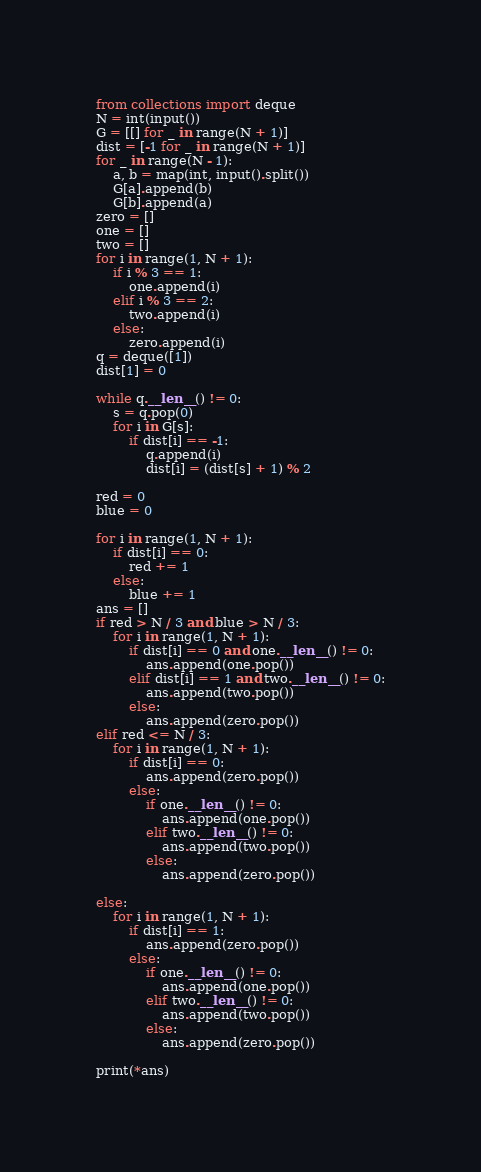<code> <loc_0><loc_0><loc_500><loc_500><_Python_>from collections import deque
N = int(input())
G = [[] for _ in range(N + 1)]
dist = [-1 for _ in range(N + 1)]
for _ in range(N - 1):
    a, b = map(int, input().split())
    G[a].append(b)
    G[b].append(a)
zero = []
one = []
two = []
for i in range(1, N + 1):
    if i % 3 == 1:
        one.append(i)
    elif i % 3 == 2:
        two.append(i)
    else:
        zero.append(i)
q = deque([1])
dist[1] = 0

while q.__len__() != 0:
    s = q.pop(0)
    for i in G[s]:
        if dist[i] == -1:
            q.append(i)
            dist[i] = (dist[s] + 1) % 2

red = 0
blue = 0

for i in range(1, N + 1):
    if dist[i] == 0:
        red += 1
    else:
        blue += 1
ans = []
if red > N / 3 and blue > N / 3:
    for i in range(1, N + 1):
        if dist[i] == 0 and one.__len__() != 0:
            ans.append(one.pop())
        elif dist[i] == 1 and two.__len__() != 0:
            ans.append(two.pop())
        else:
            ans.append(zero.pop())
elif red <= N / 3:
    for i in range(1, N + 1):
        if dist[i] == 0:
            ans.append(zero.pop())
        else:
            if one.__len__() != 0:
                ans.append(one.pop())
            elif two.__len__() != 0:
                ans.append(two.pop())
            else:
                ans.append(zero.pop())

else:
    for i in range(1, N + 1):
        if dist[i] == 1:
            ans.append(zero.pop())
        else:
            if one.__len__() != 0:
                ans.append(one.pop())
            elif two.__len__() != 0:
                ans.append(two.pop())
            else:
                ans.append(zero.pop())

print(*ans)
</code> 